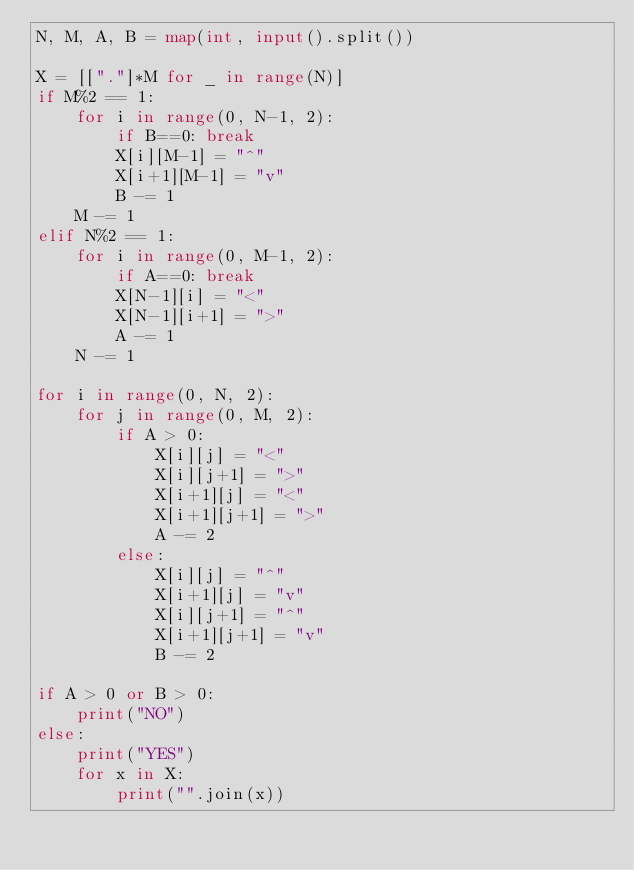Convert code to text. <code><loc_0><loc_0><loc_500><loc_500><_Python_>N, M, A, B = map(int, input().split())

X = [["."]*M for _ in range(N)]
if M%2 == 1:
    for i in range(0, N-1, 2):
        if B==0: break
        X[i][M-1] = "^"
        X[i+1][M-1] = "v"
        B -= 1
    M -= 1
elif N%2 == 1:
    for i in range(0, M-1, 2):
        if A==0: break
        X[N-1][i] = "<"
        X[N-1][i+1] = ">"
        A -= 1
    N -= 1

for i in range(0, N, 2):
    for j in range(0, M, 2):
        if A > 0:
            X[i][j] = "<"
            X[i][j+1] = ">"
            X[i+1][j] = "<"
            X[i+1][j+1] = ">"
            A -= 2
        else:
            X[i][j] = "^"
            X[i+1][j] = "v"
            X[i][j+1] = "^"
            X[i+1][j+1] = "v"
            B -= 2

if A > 0 or B > 0:
    print("NO")
else:
    print("YES")
    for x in X:
        print("".join(x))</code> 